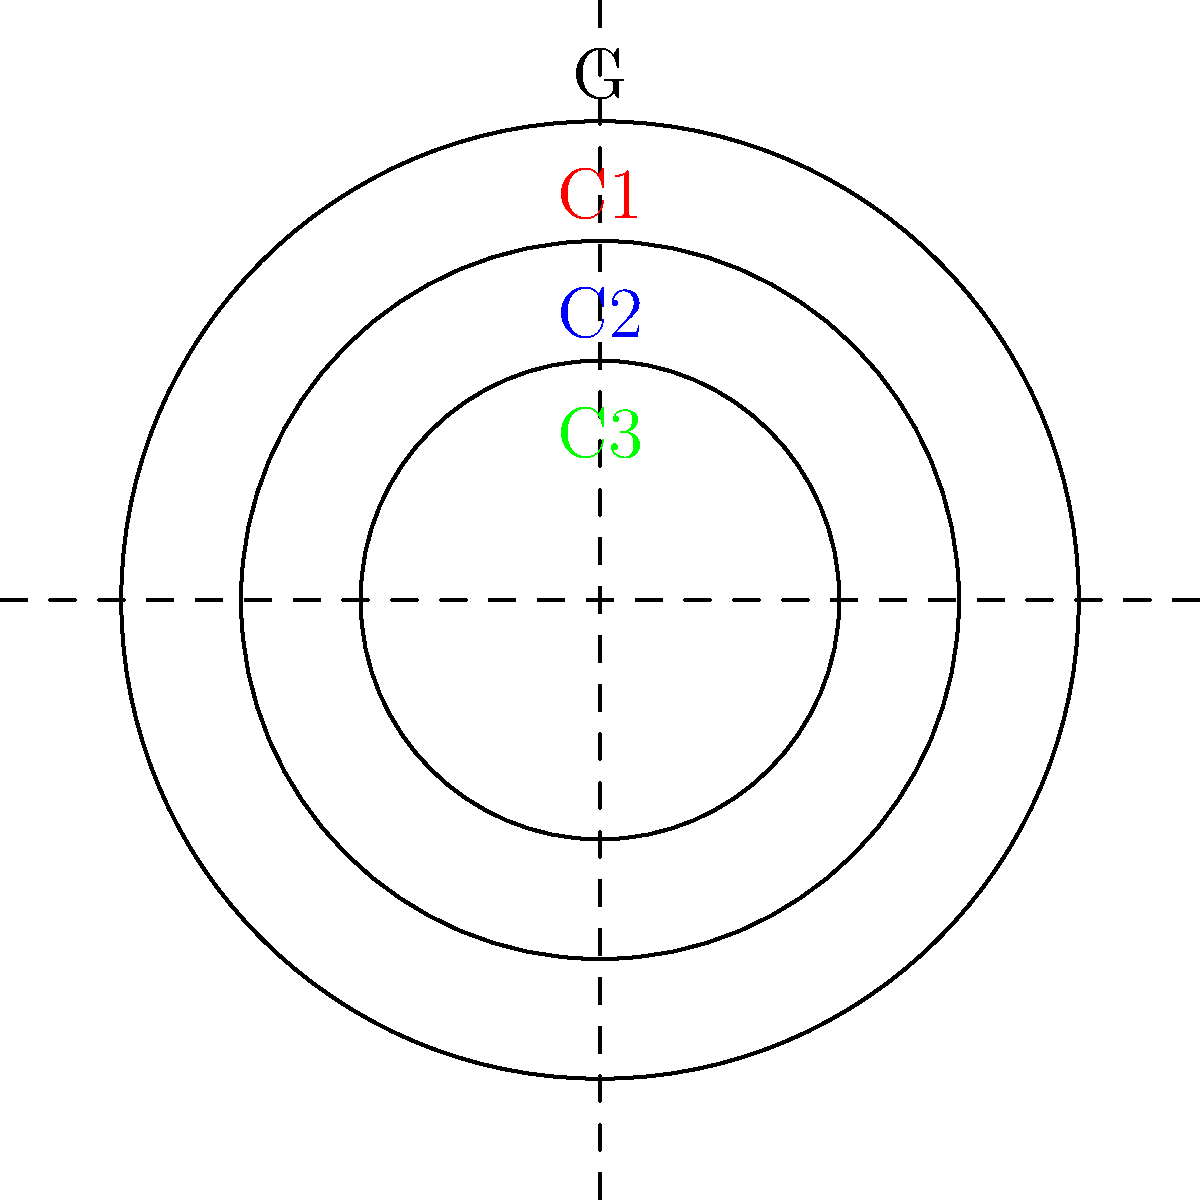In the context of group theory, the diagram represents the conjugacy classes of a group $G$. Given that $|G| = 24$ and the sizes of the conjugacy classes are $|C_1| = 6$, $|C_2| = 8$, and $|C_3| = 9$, what is the size of the center of the group, $|Z(G)|$? To find the size of the center of the group, we can follow these steps:

1) Recall that the center of a group $Z(G)$ is the set of elements that commute with every element in the group. These elements form their own conjugacy class of size 1.

2) The class equation for a finite group $G$ is:
   $|G| = |Z(G)| + \sum_{i=1}^{k} |C_i|$
   where $C_i$ are the non-central conjugacy classes.

3) We're given:
   $|G| = 24$
   $|C_1| = 6$
   $|C_2| = 8$
   $|C_3| = 9$

4) Substituting these into the class equation:
   $24 = |Z(G)| + 6 + 8 + 9$

5) Simplifying:
   $24 = |Z(G)| + 23$

6) Solving for $|Z(G)|$:
   $|Z(G)| = 24 - 23 = 1$

Therefore, the size of the center of the group is 1.
Answer: $|Z(G)| = 1$ 